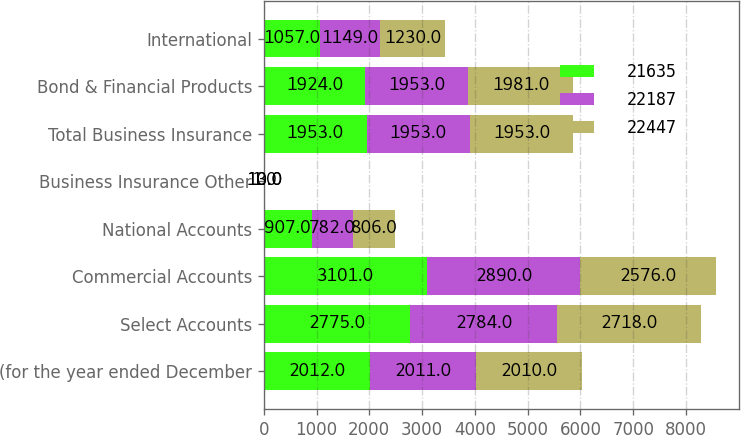<chart> <loc_0><loc_0><loc_500><loc_500><stacked_bar_chart><ecel><fcel>(for the year ended December<fcel>Select Accounts<fcel>Commercial Accounts<fcel>National Accounts<fcel>Business Insurance Other<fcel>Total Business Insurance<fcel>Bond & Financial Products<fcel>International<nl><fcel>21635<fcel>2012<fcel>2775<fcel>3101<fcel>907<fcel>1<fcel>1953<fcel>1924<fcel>1057<nl><fcel>22187<fcel>2011<fcel>2784<fcel>2890<fcel>782<fcel>10<fcel>1953<fcel>1953<fcel>1149<nl><fcel>22447<fcel>2010<fcel>2718<fcel>2576<fcel>806<fcel>13<fcel>1953<fcel>1981<fcel>1230<nl></chart> 